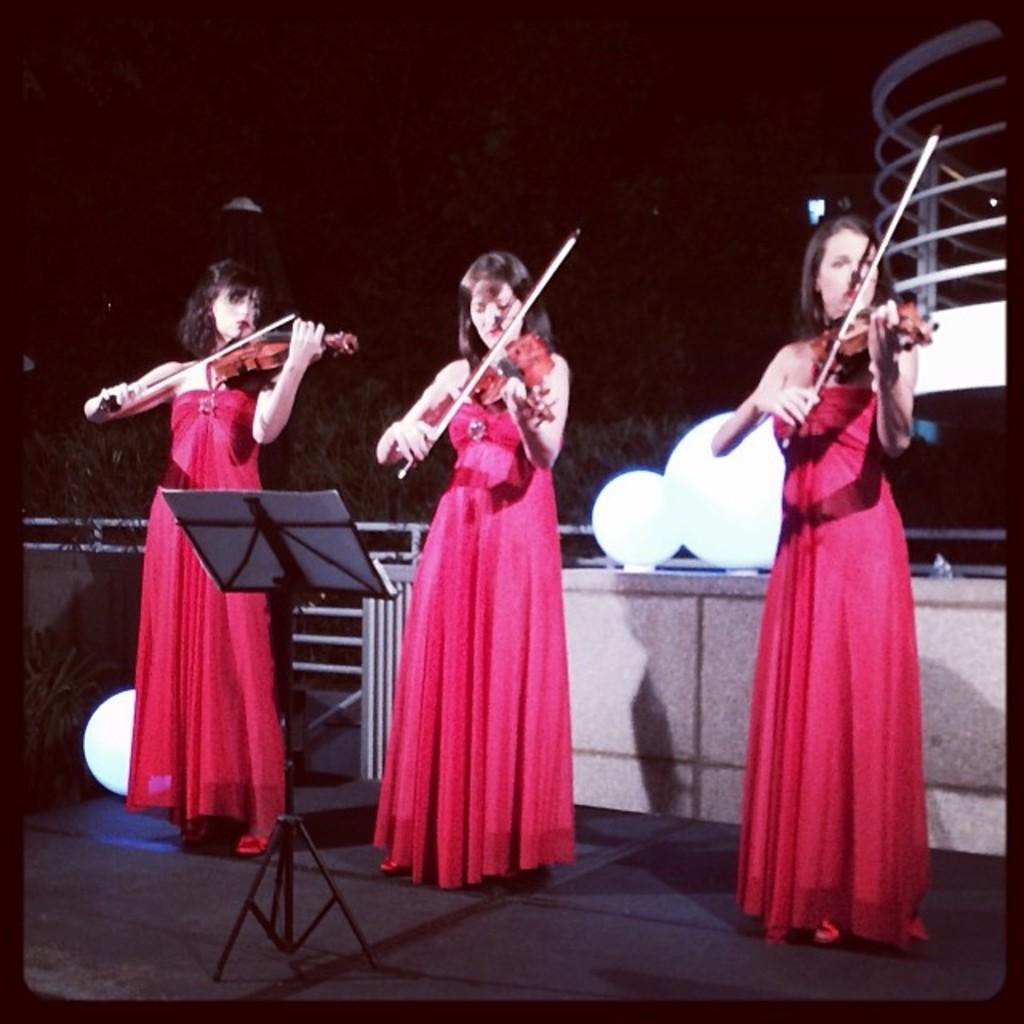Describe this image in one or two sentences. In this picture we can observe three women playing violins in their hands. All of them were wearing pink color dresses. In front of them there is a stand on which we can observe a book. In the background there are trees and it is dark. 